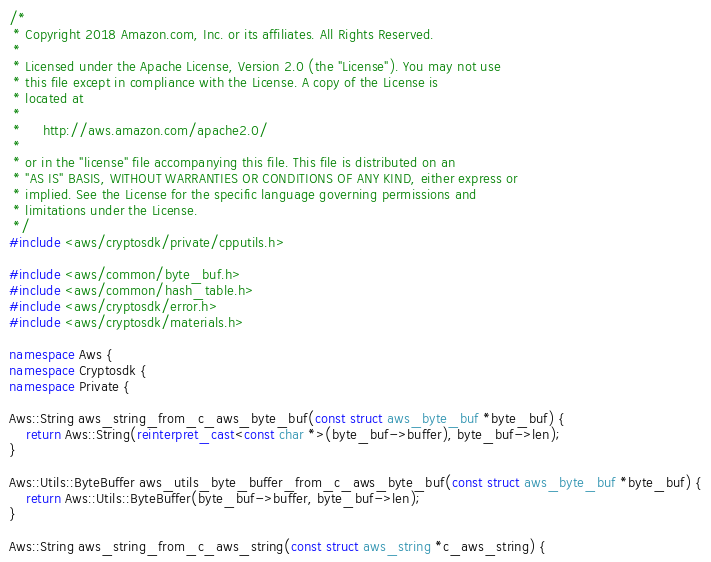<code> <loc_0><loc_0><loc_500><loc_500><_C++_>/*
 * Copyright 2018 Amazon.com, Inc. or its affiliates. All Rights Reserved.
 *
 * Licensed under the Apache License, Version 2.0 (the "License"). You may not use
 * this file except in compliance with the License. A copy of the License is
 * located at
 *
 *     http://aws.amazon.com/apache2.0/
 *
 * or in the "license" file accompanying this file. This file is distributed on an
 * "AS IS" BASIS, WITHOUT WARRANTIES OR CONDITIONS OF ANY KIND, either express or
 * implied. See the License for the specific language governing permissions and
 * limitations under the License.
 */
#include <aws/cryptosdk/private/cpputils.h>

#include <aws/common/byte_buf.h>
#include <aws/common/hash_table.h>
#include <aws/cryptosdk/error.h>
#include <aws/cryptosdk/materials.h>

namespace Aws {
namespace Cryptosdk {
namespace Private {

Aws::String aws_string_from_c_aws_byte_buf(const struct aws_byte_buf *byte_buf) {
    return Aws::String(reinterpret_cast<const char *>(byte_buf->buffer), byte_buf->len);
}

Aws::Utils::ByteBuffer aws_utils_byte_buffer_from_c_aws_byte_buf(const struct aws_byte_buf *byte_buf) {
    return Aws::Utils::ByteBuffer(byte_buf->buffer, byte_buf->len);
}

Aws::String aws_string_from_c_aws_string(const struct aws_string *c_aws_string) {</code> 